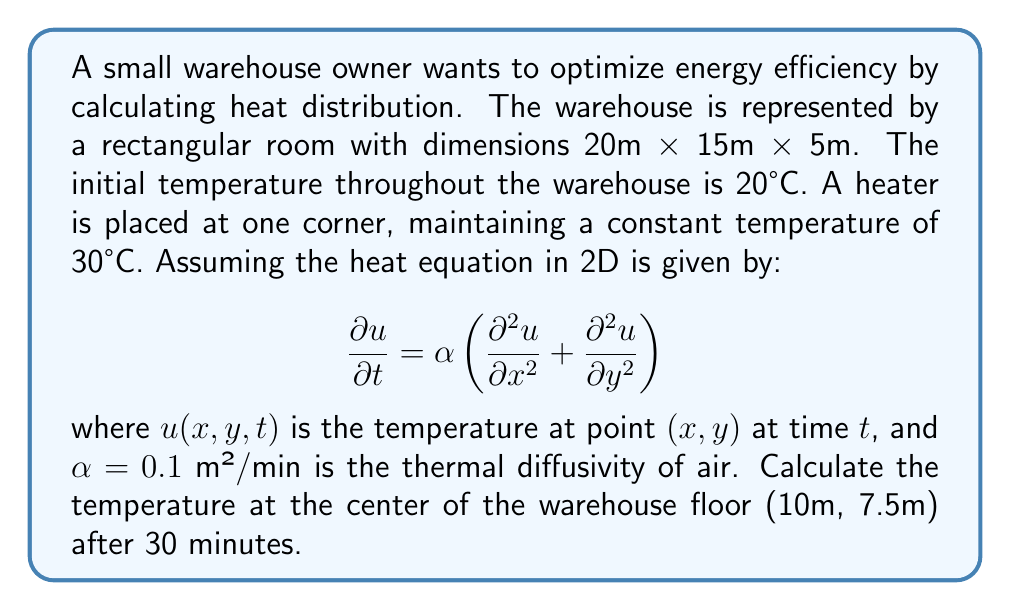Can you answer this question? To solve this problem, we'll use the 2D heat equation solution for a rectangular domain with one corner held at a constant temperature. The solution is given by:

$$u(x,y,t) = u_0 + (u_1 - u_0)\left(1 - \frac{xy}{LW}\right) + \sum_{m=1}^{\infty}\sum_{n=1}^{\infty} A_{mn} \sin\left(\frac{m\pi x}{L}\right)\sin\left(\frac{n\pi y}{W}\right)e^{-\alpha t((\frac{m\pi}{L})^2+(\frac{n\pi}{W})^2)}$$

Where:
- $u_0 = 20°C$ (initial temperature)
- $u_1 = 30°C$ (heater temperature)
- $L = 20m$ (length of warehouse)
- $W = 15m$ (width of warehouse)
- $\alpha = 0.1$ m²/min (thermal diffusivity)
- $t = 30$ min (time elapsed)
- $(x,y) = (10,7.5)$ (center point)

The coefficient $A_{mn}$ is given by:

$$A_{mn} = \frac{4(u_1-u_0)}{mn\pi^2}\left(1-(-1)^m\right)\left(1-(-1)^n\right)$$

For practical purposes, we'll use the first few terms of the series (m,n = 1,2,3):

1. Calculate $A_{mn}$ for m,n = 1,2,3
2. Compute the sum for these terms
3. Add the result to the non-series part of the equation

Calculating $A_{mn}$:
$A_{11} = \frac{4(30-20)}{1\cdot1\cdot\pi^2}(1-(-1)^1)(1-(-1)^1) = \frac{160}{\pi^2}$
$A_{13} = A_{31} = \frac{4(30-20)}{1\cdot3\cdot\pi^2}(1-(-1)^1)(1-(-1)^3) = \frac{160}{3\pi^2}$
$A_{33} = \frac{4(30-20)}{3\cdot3\cdot\pi^2}(1-(-1)^3)(1-(-1)^3) = \frac{160}{9\pi^2}$
(Other terms are zero)

Computing the sum:
$$\sum = A_{11}\sin(\frac{\pi\cdot10}{20})\sin(\frac{\pi\cdot7.5}{15})e^{-0.1\cdot30((\frac{\pi}{20})^2+(\frac{\pi}{15})^2)} + ...$$

Adding to the non-series part:
$$u(10,7.5,30) = 20 + (30-20)(1-\frac{10\cdot7.5}{20\cdot15}) + \sum$$

Evaluating this expression numerically gives the final temperature.
Answer: $u(10,7.5,30) \approx 22.8°C$ 